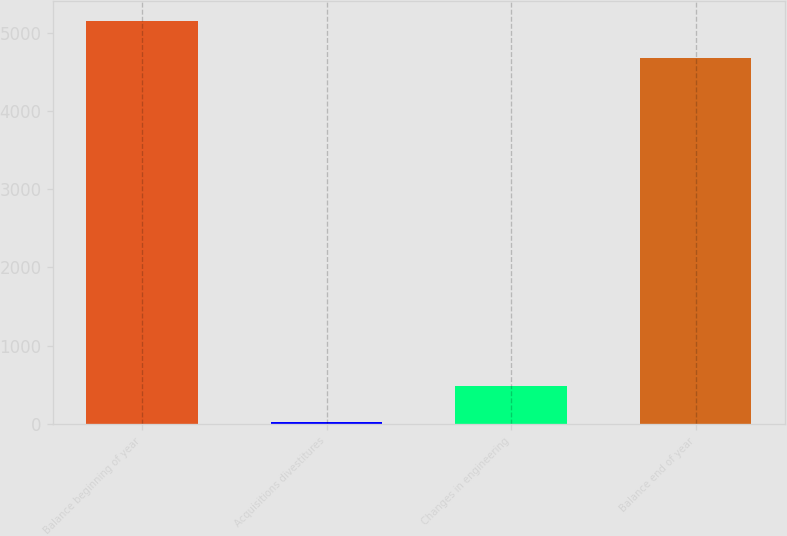Convert chart. <chart><loc_0><loc_0><loc_500><loc_500><bar_chart><fcel>Balance beginning of year<fcel>Acquisitions divestitures<fcel>Changes in engineering<fcel>Balance end of year<nl><fcel>5149.9<fcel>20<fcel>489.9<fcel>4680<nl></chart> 